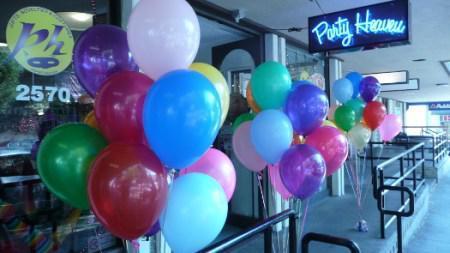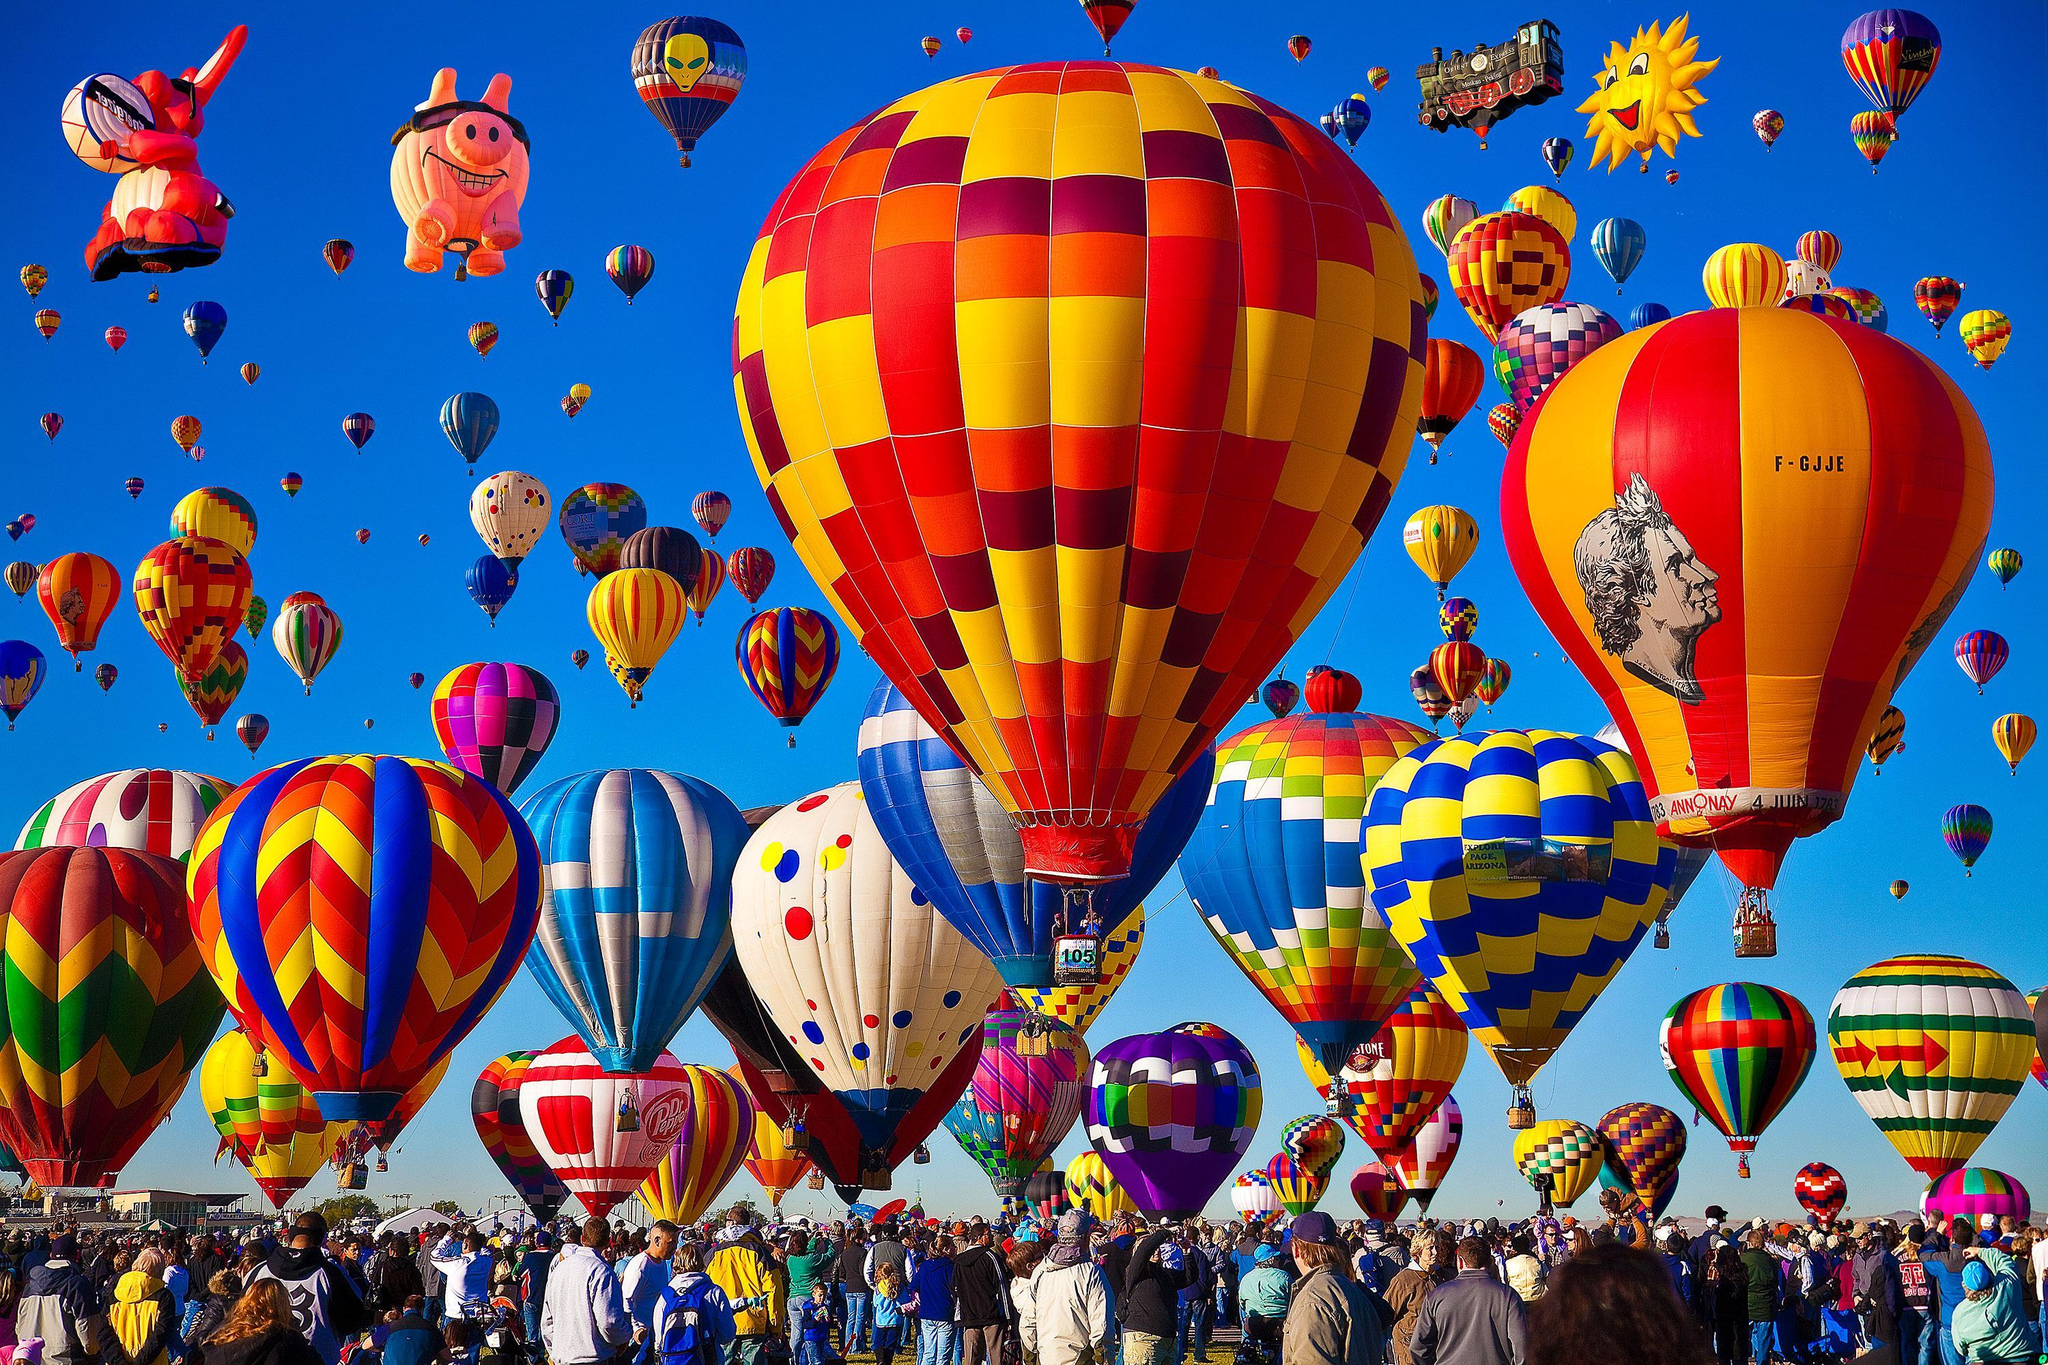The first image is the image on the left, the second image is the image on the right. Evaluate the accuracy of this statement regarding the images: "There are at least 15 balloons inside a party shop or ballon store.". Is it true? Answer yes or no. No. The first image is the image on the left, the second image is the image on the right. For the images displayed, is the sentence "There are solid red balloons in the right image, and green balloons in the left." factually correct? Answer yes or no. No. 